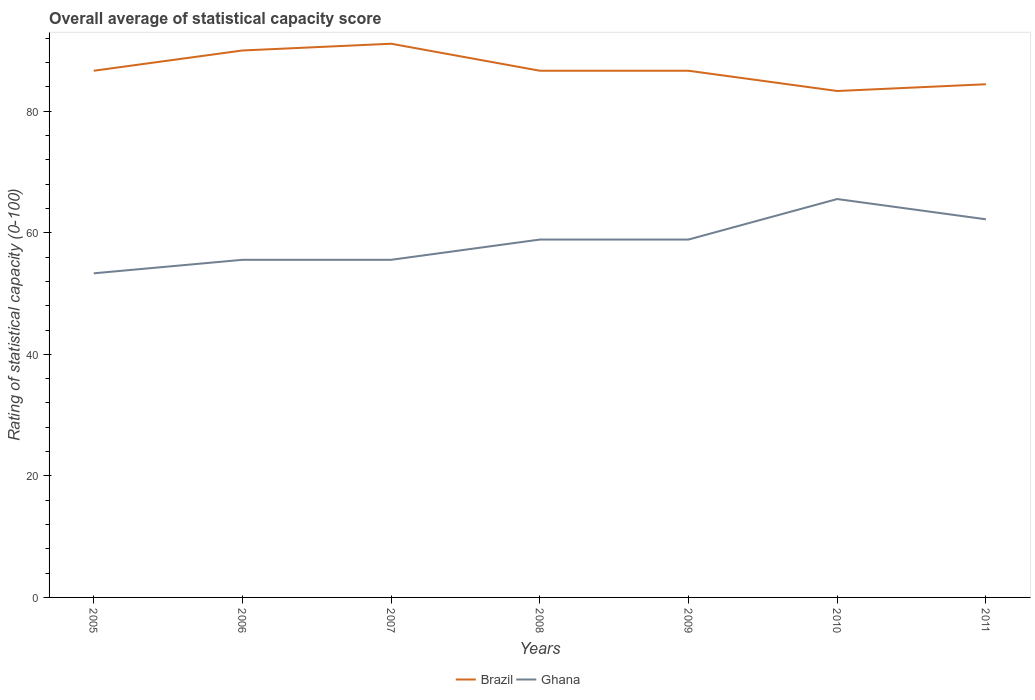Is the number of lines equal to the number of legend labels?
Your answer should be very brief. Yes. Across all years, what is the maximum rating of statistical capacity in Ghana?
Your response must be concise. 53.33. What is the total rating of statistical capacity in Ghana in the graph?
Your response must be concise. 0. What is the difference between the highest and the second highest rating of statistical capacity in Ghana?
Make the answer very short. 12.22. Is the rating of statistical capacity in Brazil strictly greater than the rating of statistical capacity in Ghana over the years?
Provide a succinct answer. No. How many years are there in the graph?
Offer a terse response. 7. What is the difference between two consecutive major ticks on the Y-axis?
Your response must be concise. 20. Does the graph contain any zero values?
Provide a short and direct response. No. Does the graph contain grids?
Your answer should be compact. No. What is the title of the graph?
Keep it short and to the point. Overall average of statistical capacity score. Does "St. Martin (French part)" appear as one of the legend labels in the graph?
Make the answer very short. No. What is the label or title of the X-axis?
Your answer should be very brief. Years. What is the label or title of the Y-axis?
Provide a succinct answer. Rating of statistical capacity (0-100). What is the Rating of statistical capacity (0-100) of Brazil in 2005?
Offer a very short reply. 86.67. What is the Rating of statistical capacity (0-100) of Ghana in 2005?
Make the answer very short. 53.33. What is the Rating of statistical capacity (0-100) of Brazil in 2006?
Offer a terse response. 90. What is the Rating of statistical capacity (0-100) in Ghana in 2006?
Your response must be concise. 55.56. What is the Rating of statistical capacity (0-100) of Brazil in 2007?
Offer a very short reply. 91.11. What is the Rating of statistical capacity (0-100) in Ghana in 2007?
Provide a succinct answer. 55.56. What is the Rating of statistical capacity (0-100) in Brazil in 2008?
Your response must be concise. 86.67. What is the Rating of statistical capacity (0-100) of Ghana in 2008?
Provide a short and direct response. 58.89. What is the Rating of statistical capacity (0-100) of Brazil in 2009?
Offer a terse response. 86.67. What is the Rating of statistical capacity (0-100) of Ghana in 2009?
Give a very brief answer. 58.89. What is the Rating of statistical capacity (0-100) of Brazil in 2010?
Ensure brevity in your answer.  83.33. What is the Rating of statistical capacity (0-100) in Ghana in 2010?
Provide a succinct answer. 65.56. What is the Rating of statistical capacity (0-100) in Brazil in 2011?
Your answer should be compact. 84.44. What is the Rating of statistical capacity (0-100) of Ghana in 2011?
Offer a very short reply. 62.22. Across all years, what is the maximum Rating of statistical capacity (0-100) of Brazil?
Offer a terse response. 91.11. Across all years, what is the maximum Rating of statistical capacity (0-100) of Ghana?
Your response must be concise. 65.56. Across all years, what is the minimum Rating of statistical capacity (0-100) of Brazil?
Your answer should be very brief. 83.33. Across all years, what is the minimum Rating of statistical capacity (0-100) in Ghana?
Provide a succinct answer. 53.33. What is the total Rating of statistical capacity (0-100) in Brazil in the graph?
Your answer should be compact. 608.89. What is the total Rating of statistical capacity (0-100) of Ghana in the graph?
Provide a short and direct response. 410. What is the difference between the Rating of statistical capacity (0-100) of Ghana in 2005 and that in 2006?
Your response must be concise. -2.22. What is the difference between the Rating of statistical capacity (0-100) in Brazil in 2005 and that in 2007?
Your answer should be compact. -4.44. What is the difference between the Rating of statistical capacity (0-100) of Ghana in 2005 and that in 2007?
Your answer should be compact. -2.22. What is the difference between the Rating of statistical capacity (0-100) in Ghana in 2005 and that in 2008?
Ensure brevity in your answer.  -5.56. What is the difference between the Rating of statistical capacity (0-100) of Ghana in 2005 and that in 2009?
Your answer should be very brief. -5.56. What is the difference between the Rating of statistical capacity (0-100) of Ghana in 2005 and that in 2010?
Ensure brevity in your answer.  -12.22. What is the difference between the Rating of statistical capacity (0-100) in Brazil in 2005 and that in 2011?
Offer a terse response. 2.22. What is the difference between the Rating of statistical capacity (0-100) in Ghana in 2005 and that in 2011?
Your answer should be compact. -8.89. What is the difference between the Rating of statistical capacity (0-100) of Brazil in 2006 and that in 2007?
Provide a short and direct response. -1.11. What is the difference between the Rating of statistical capacity (0-100) of Ghana in 2006 and that in 2007?
Give a very brief answer. 0. What is the difference between the Rating of statistical capacity (0-100) in Ghana in 2006 and that in 2008?
Offer a terse response. -3.33. What is the difference between the Rating of statistical capacity (0-100) of Brazil in 2006 and that in 2009?
Provide a succinct answer. 3.33. What is the difference between the Rating of statistical capacity (0-100) of Brazil in 2006 and that in 2010?
Ensure brevity in your answer.  6.67. What is the difference between the Rating of statistical capacity (0-100) of Ghana in 2006 and that in 2010?
Make the answer very short. -10. What is the difference between the Rating of statistical capacity (0-100) of Brazil in 2006 and that in 2011?
Provide a short and direct response. 5.56. What is the difference between the Rating of statistical capacity (0-100) of Ghana in 2006 and that in 2011?
Keep it short and to the point. -6.67. What is the difference between the Rating of statistical capacity (0-100) in Brazil in 2007 and that in 2008?
Ensure brevity in your answer.  4.44. What is the difference between the Rating of statistical capacity (0-100) of Ghana in 2007 and that in 2008?
Your answer should be very brief. -3.33. What is the difference between the Rating of statistical capacity (0-100) of Brazil in 2007 and that in 2009?
Make the answer very short. 4.44. What is the difference between the Rating of statistical capacity (0-100) of Ghana in 2007 and that in 2009?
Give a very brief answer. -3.33. What is the difference between the Rating of statistical capacity (0-100) of Brazil in 2007 and that in 2010?
Ensure brevity in your answer.  7.78. What is the difference between the Rating of statistical capacity (0-100) in Ghana in 2007 and that in 2010?
Keep it short and to the point. -10. What is the difference between the Rating of statistical capacity (0-100) in Brazil in 2007 and that in 2011?
Provide a succinct answer. 6.67. What is the difference between the Rating of statistical capacity (0-100) in Ghana in 2007 and that in 2011?
Offer a terse response. -6.67. What is the difference between the Rating of statistical capacity (0-100) in Brazil in 2008 and that in 2009?
Offer a terse response. 0. What is the difference between the Rating of statistical capacity (0-100) of Ghana in 2008 and that in 2010?
Make the answer very short. -6.67. What is the difference between the Rating of statistical capacity (0-100) in Brazil in 2008 and that in 2011?
Make the answer very short. 2.22. What is the difference between the Rating of statistical capacity (0-100) of Ghana in 2009 and that in 2010?
Offer a very short reply. -6.67. What is the difference between the Rating of statistical capacity (0-100) of Brazil in 2009 and that in 2011?
Your response must be concise. 2.22. What is the difference between the Rating of statistical capacity (0-100) in Brazil in 2010 and that in 2011?
Your response must be concise. -1.11. What is the difference between the Rating of statistical capacity (0-100) of Ghana in 2010 and that in 2011?
Your response must be concise. 3.33. What is the difference between the Rating of statistical capacity (0-100) of Brazil in 2005 and the Rating of statistical capacity (0-100) of Ghana in 2006?
Offer a very short reply. 31.11. What is the difference between the Rating of statistical capacity (0-100) of Brazil in 2005 and the Rating of statistical capacity (0-100) of Ghana in 2007?
Make the answer very short. 31.11. What is the difference between the Rating of statistical capacity (0-100) in Brazil in 2005 and the Rating of statistical capacity (0-100) in Ghana in 2008?
Make the answer very short. 27.78. What is the difference between the Rating of statistical capacity (0-100) in Brazil in 2005 and the Rating of statistical capacity (0-100) in Ghana in 2009?
Keep it short and to the point. 27.78. What is the difference between the Rating of statistical capacity (0-100) of Brazil in 2005 and the Rating of statistical capacity (0-100) of Ghana in 2010?
Your response must be concise. 21.11. What is the difference between the Rating of statistical capacity (0-100) in Brazil in 2005 and the Rating of statistical capacity (0-100) in Ghana in 2011?
Offer a very short reply. 24.44. What is the difference between the Rating of statistical capacity (0-100) in Brazil in 2006 and the Rating of statistical capacity (0-100) in Ghana in 2007?
Give a very brief answer. 34.44. What is the difference between the Rating of statistical capacity (0-100) in Brazil in 2006 and the Rating of statistical capacity (0-100) in Ghana in 2008?
Your response must be concise. 31.11. What is the difference between the Rating of statistical capacity (0-100) in Brazil in 2006 and the Rating of statistical capacity (0-100) in Ghana in 2009?
Make the answer very short. 31.11. What is the difference between the Rating of statistical capacity (0-100) of Brazil in 2006 and the Rating of statistical capacity (0-100) of Ghana in 2010?
Make the answer very short. 24.44. What is the difference between the Rating of statistical capacity (0-100) in Brazil in 2006 and the Rating of statistical capacity (0-100) in Ghana in 2011?
Give a very brief answer. 27.78. What is the difference between the Rating of statistical capacity (0-100) in Brazil in 2007 and the Rating of statistical capacity (0-100) in Ghana in 2008?
Offer a very short reply. 32.22. What is the difference between the Rating of statistical capacity (0-100) in Brazil in 2007 and the Rating of statistical capacity (0-100) in Ghana in 2009?
Offer a very short reply. 32.22. What is the difference between the Rating of statistical capacity (0-100) of Brazil in 2007 and the Rating of statistical capacity (0-100) of Ghana in 2010?
Offer a very short reply. 25.56. What is the difference between the Rating of statistical capacity (0-100) of Brazil in 2007 and the Rating of statistical capacity (0-100) of Ghana in 2011?
Your response must be concise. 28.89. What is the difference between the Rating of statistical capacity (0-100) of Brazil in 2008 and the Rating of statistical capacity (0-100) of Ghana in 2009?
Keep it short and to the point. 27.78. What is the difference between the Rating of statistical capacity (0-100) in Brazil in 2008 and the Rating of statistical capacity (0-100) in Ghana in 2010?
Ensure brevity in your answer.  21.11. What is the difference between the Rating of statistical capacity (0-100) in Brazil in 2008 and the Rating of statistical capacity (0-100) in Ghana in 2011?
Ensure brevity in your answer.  24.44. What is the difference between the Rating of statistical capacity (0-100) in Brazil in 2009 and the Rating of statistical capacity (0-100) in Ghana in 2010?
Ensure brevity in your answer.  21.11. What is the difference between the Rating of statistical capacity (0-100) of Brazil in 2009 and the Rating of statistical capacity (0-100) of Ghana in 2011?
Keep it short and to the point. 24.44. What is the difference between the Rating of statistical capacity (0-100) in Brazil in 2010 and the Rating of statistical capacity (0-100) in Ghana in 2011?
Ensure brevity in your answer.  21.11. What is the average Rating of statistical capacity (0-100) of Brazil per year?
Offer a very short reply. 86.98. What is the average Rating of statistical capacity (0-100) in Ghana per year?
Your answer should be very brief. 58.57. In the year 2005, what is the difference between the Rating of statistical capacity (0-100) of Brazil and Rating of statistical capacity (0-100) of Ghana?
Offer a terse response. 33.33. In the year 2006, what is the difference between the Rating of statistical capacity (0-100) of Brazil and Rating of statistical capacity (0-100) of Ghana?
Your answer should be compact. 34.44. In the year 2007, what is the difference between the Rating of statistical capacity (0-100) in Brazil and Rating of statistical capacity (0-100) in Ghana?
Your answer should be compact. 35.56. In the year 2008, what is the difference between the Rating of statistical capacity (0-100) of Brazil and Rating of statistical capacity (0-100) of Ghana?
Offer a very short reply. 27.78. In the year 2009, what is the difference between the Rating of statistical capacity (0-100) of Brazil and Rating of statistical capacity (0-100) of Ghana?
Make the answer very short. 27.78. In the year 2010, what is the difference between the Rating of statistical capacity (0-100) of Brazil and Rating of statistical capacity (0-100) of Ghana?
Offer a very short reply. 17.78. In the year 2011, what is the difference between the Rating of statistical capacity (0-100) in Brazil and Rating of statistical capacity (0-100) in Ghana?
Provide a short and direct response. 22.22. What is the ratio of the Rating of statistical capacity (0-100) of Ghana in 2005 to that in 2006?
Your answer should be very brief. 0.96. What is the ratio of the Rating of statistical capacity (0-100) of Brazil in 2005 to that in 2007?
Provide a short and direct response. 0.95. What is the ratio of the Rating of statistical capacity (0-100) of Ghana in 2005 to that in 2007?
Provide a succinct answer. 0.96. What is the ratio of the Rating of statistical capacity (0-100) in Ghana in 2005 to that in 2008?
Keep it short and to the point. 0.91. What is the ratio of the Rating of statistical capacity (0-100) of Brazil in 2005 to that in 2009?
Make the answer very short. 1. What is the ratio of the Rating of statistical capacity (0-100) of Ghana in 2005 to that in 2009?
Your answer should be compact. 0.91. What is the ratio of the Rating of statistical capacity (0-100) in Brazil in 2005 to that in 2010?
Your answer should be compact. 1.04. What is the ratio of the Rating of statistical capacity (0-100) in Ghana in 2005 to that in 2010?
Offer a very short reply. 0.81. What is the ratio of the Rating of statistical capacity (0-100) of Brazil in 2005 to that in 2011?
Offer a terse response. 1.03. What is the ratio of the Rating of statistical capacity (0-100) of Ghana in 2006 to that in 2007?
Keep it short and to the point. 1. What is the ratio of the Rating of statistical capacity (0-100) in Ghana in 2006 to that in 2008?
Your answer should be compact. 0.94. What is the ratio of the Rating of statistical capacity (0-100) of Brazil in 2006 to that in 2009?
Your response must be concise. 1.04. What is the ratio of the Rating of statistical capacity (0-100) in Ghana in 2006 to that in 2009?
Give a very brief answer. 0.94. What is the ratio of the Rating of statistical capacity (0-100) of Brazil in 2006 to that in 2010?
Offer a terse response. 1.08. What is the ratio of the Rating of statistical capacity (0-100) in Ghana in 2006 to that in 2010?
Give a very brief answer. 0.85. What is the ratio of the Rating of statistical capacity (0-100) in Brazil in 2006 to that in 2011?
Offer a very short reply. 1.07. What is the ratio of the Rating of statistical capacity (0-100) in Ghana in 2006 to that in 2011?
Provide a succinct answer. 0.89. What is the ratio of the Rating of statistical capacity (0-100) of Brazil in 2007 to that in 2008?
Your answer should be compact. 1.05. What is the ratio of the Rating of statistical capacity (0-100) of Ghana in 2007 to that in 2008?
Offer a terse response. 0.94. What is the ratio of the Rating of statistical capacity (0-100) in Brazil in 2007 to that in 2009?
Your answer should be very brief. 1.05. What is the ratio of the Rating of statistical capacity (0-100) of Ghana in 2007 to that in 2009?
Offer a terse response. 0.94. What is the ratio of the Rating of statistical capacity (0-100) in Brazil in 2007 to that in 2010?
Give a very brief answer. 1.09. What is the ratio of the Rating of statistical capacity (0-100) in Ghana in 2007 to that in 2010?
Your answer should be compact. 0.85. What is the ratio of the Rating of statistical capacity (0-100) of Brazil in 2007 to that in 2011?
Provide a succinct answer. 1.08. What is the ratio of the Rating of statistical capacity (0-100) in Ghana in 2007 to that in 2011?
Give a very brief answer. 0.89. What is the ratio of the Rating of statistical capacity (0-100) in Brazil in 2008 to that in 2009?
Your answer should be compact. 1. What is the ratio of the Rating of statistical capacity (0-100) of Brazil in 2008 to that in 2010?
Your answer should be compact. 1.04. What is the ratio of the Rating of statistical capacity (0-100) of Ghana in 2008 to that in 2010?
Your answer should be compact. 0.9. What is the ratio of the Rating of statistical capacity (0-100) of Brazil in 2008 to that in 2011?
Your answer should be compact. 1.03. What is the ratio of the Rating of statistical capacity (0-100) of Ghana in 2008 to that in 2011?
Provide a short and direct response. 0.95. What is the ratio of the Rating of statistical capacity (0-100) of Ghana in 2009 to that in 2010?
Offer a very short reply. 0.9. What is the ratio of the Rating of statistical capacity (0-100) in Brazil in 2009 to that in 2011?
Provide a succinct answer. 1.03. What is the ratio of the Rating of statistical capacity (0-100) of Ghana in 2009 to that in 2011?
Give a very brief answer. 0.95. What is the ratio of the Rating of statistical capacity (0-100) in Ghana in 2010 to that in 2011?
Offer a terse response. 1.05. What is the difference between the highest and the second highest Rating of statistical capacity (0-100) in Brazil?
Your answer should be compact. 1.11. What is the difference between the highest and the second highest Rating of statistical capacity (0-100) of Ghana?
Your response must be concise. 3.33. What is the difference between the highest and the lowest Rating of statistical capacity (0-100) of Brazil?
Offer a very short reply. 7.78. What is the difference between the highest and the lowest Rating of statistical capacity (0-100) in Ghana?
Offer a very short reply. 12.22. 